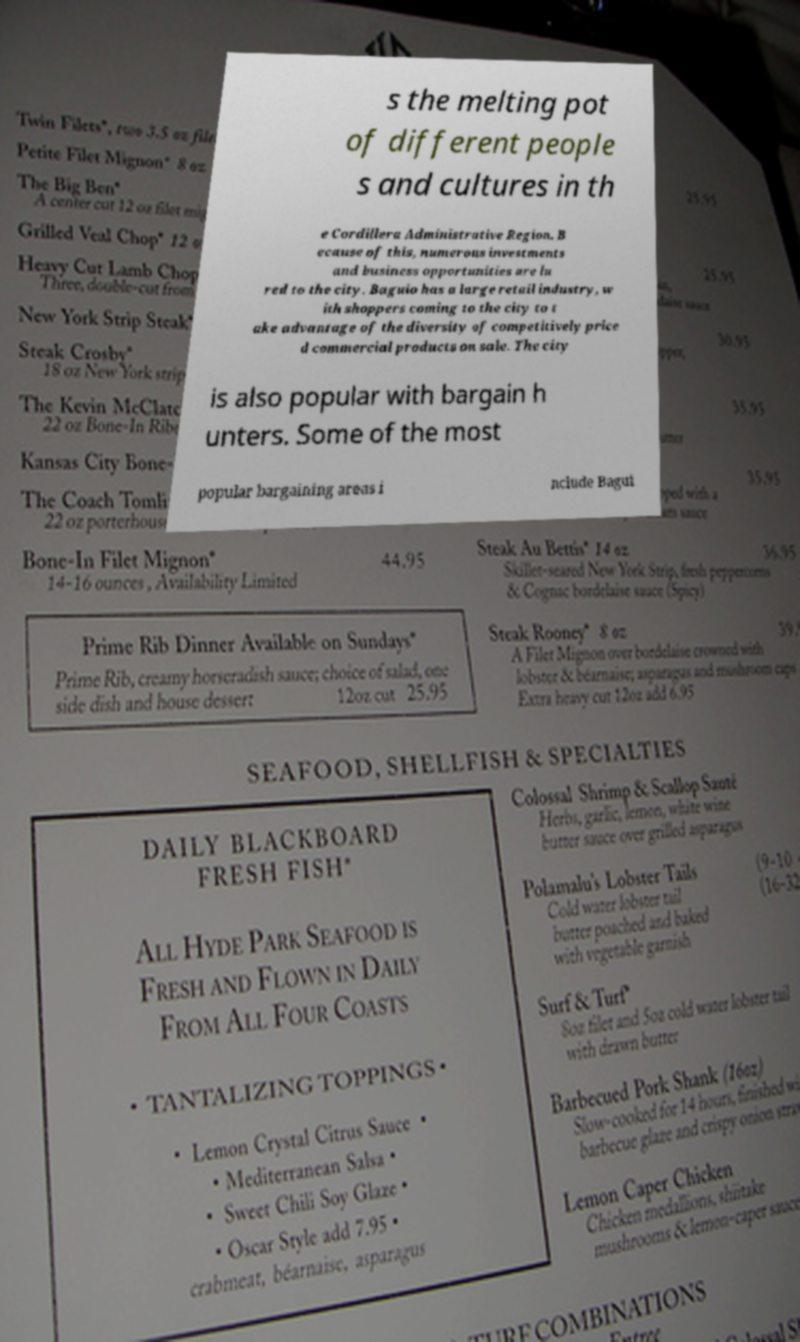Please identify and transcribe the text found in this image. s the melting pot of different people s and cultures in th e Cordillera Administrative Region. B ecause of this, numerous investments and business opportunities are lu red to the city. Baguio has a large retail industry, w ith shoppers coming to the city to t ake advantage of the diversity of competitively price d commercial products on sale. The city is also popular with bargain h unters. Some of the most popular bargaining areas i nclude Bagui 